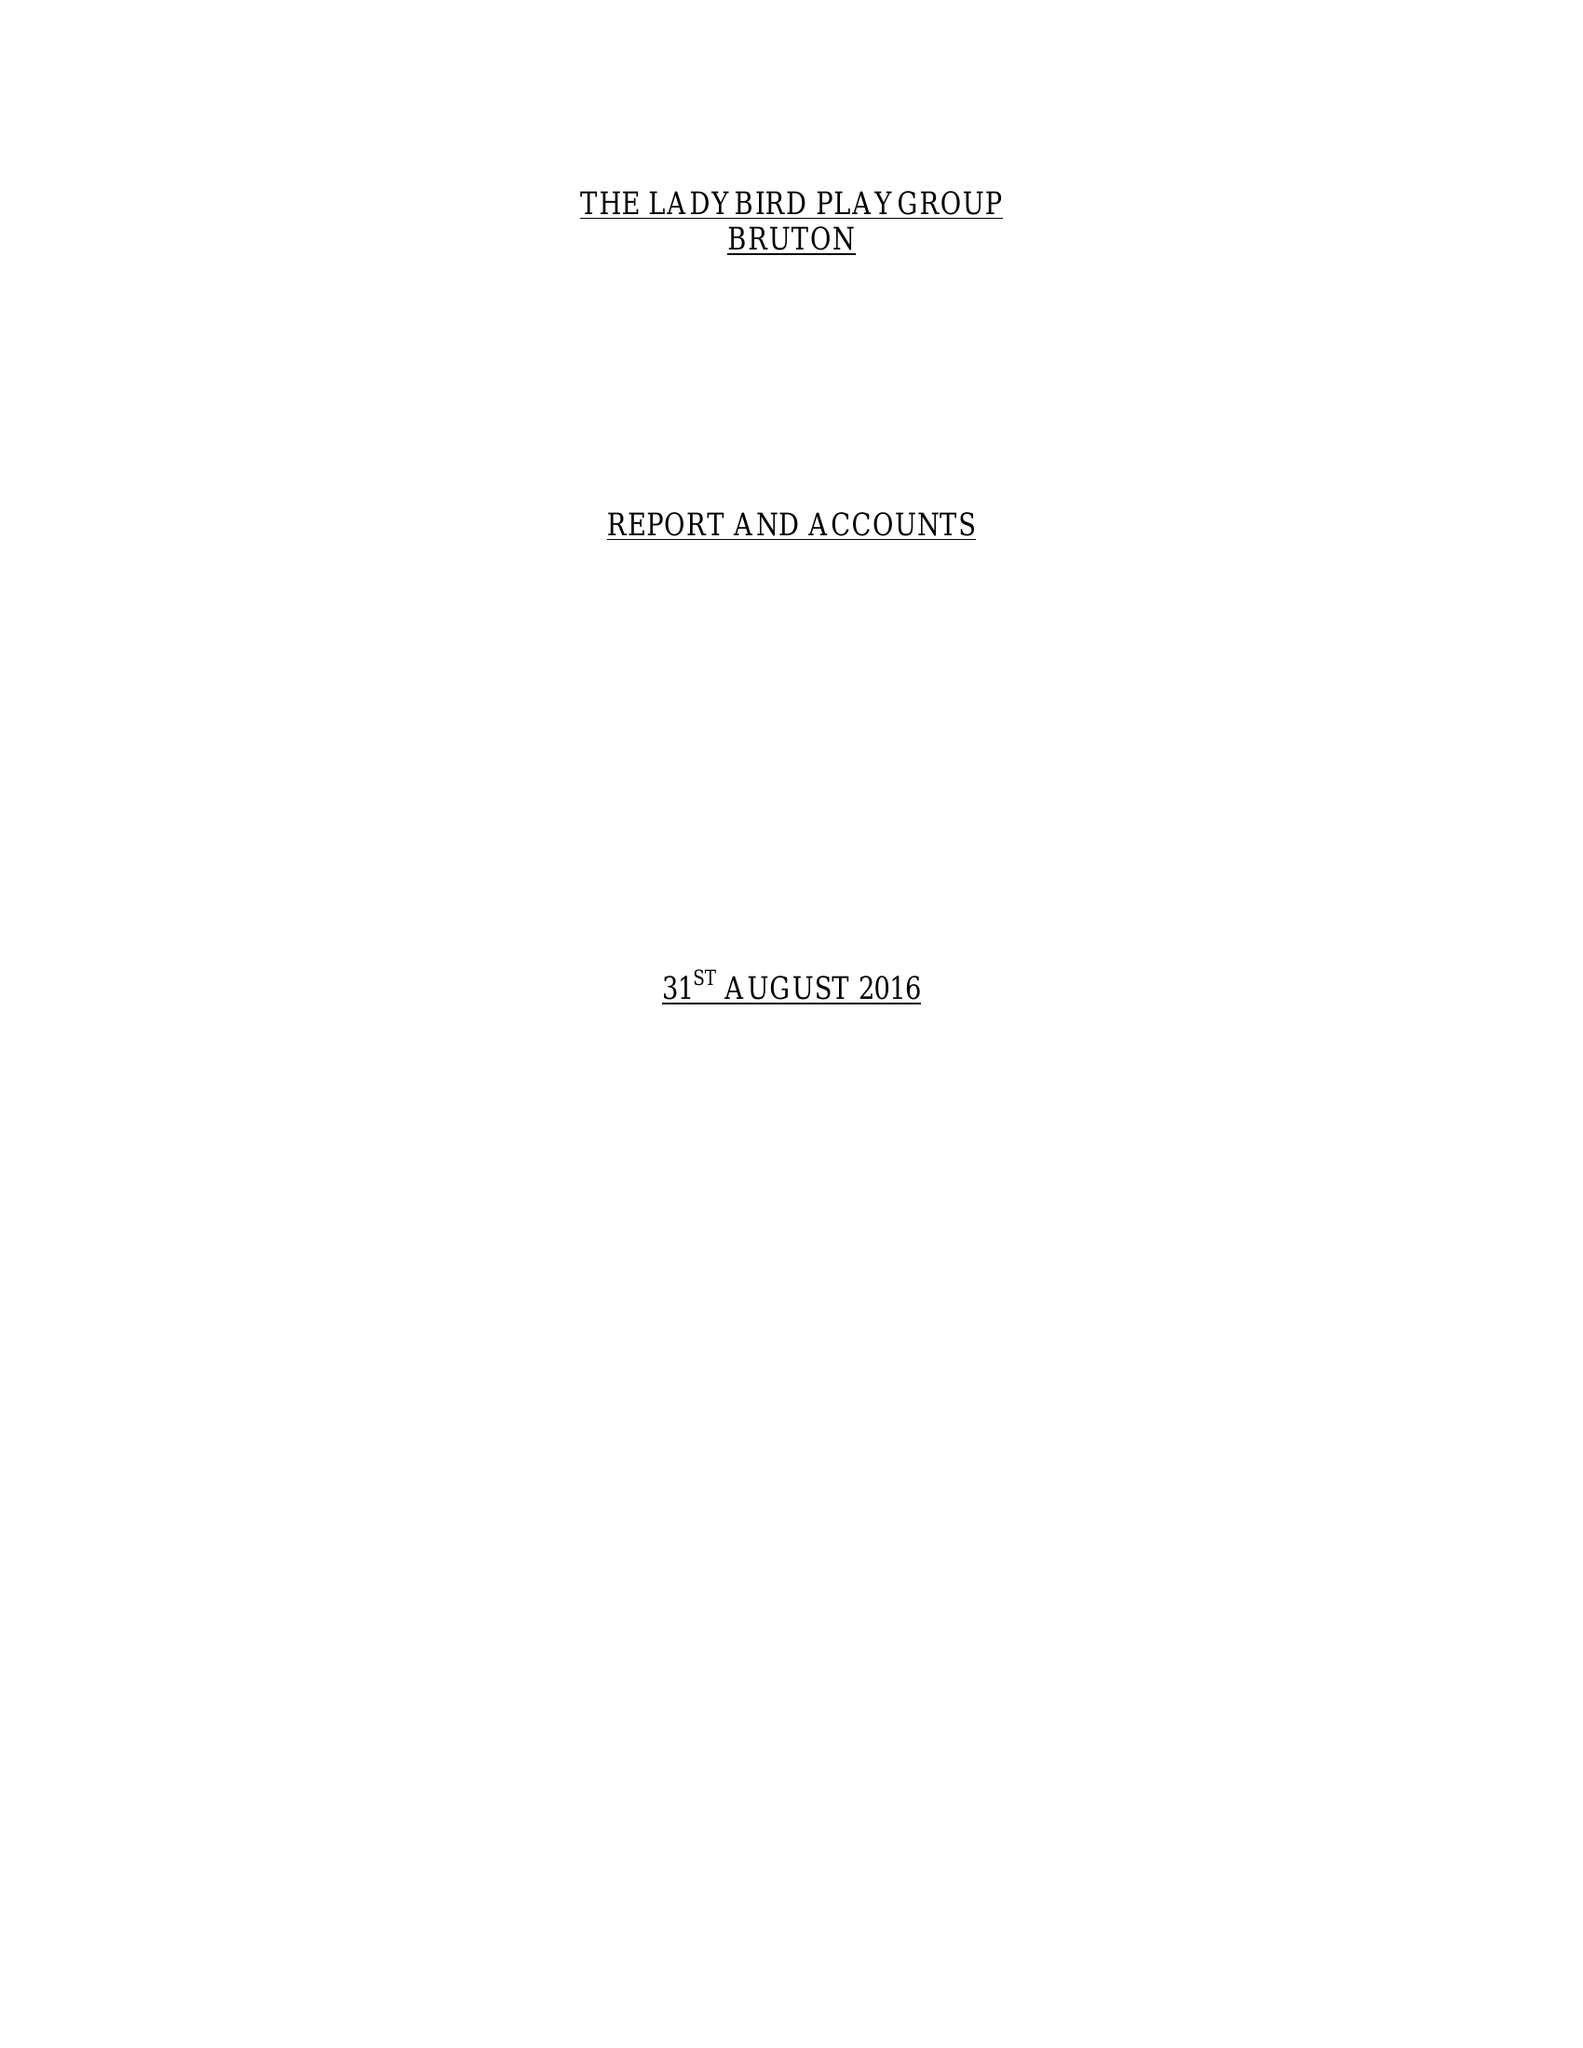What is the value for the address__street_line?
Answer the question using a single word or phrase. GODMINSTER LANE 